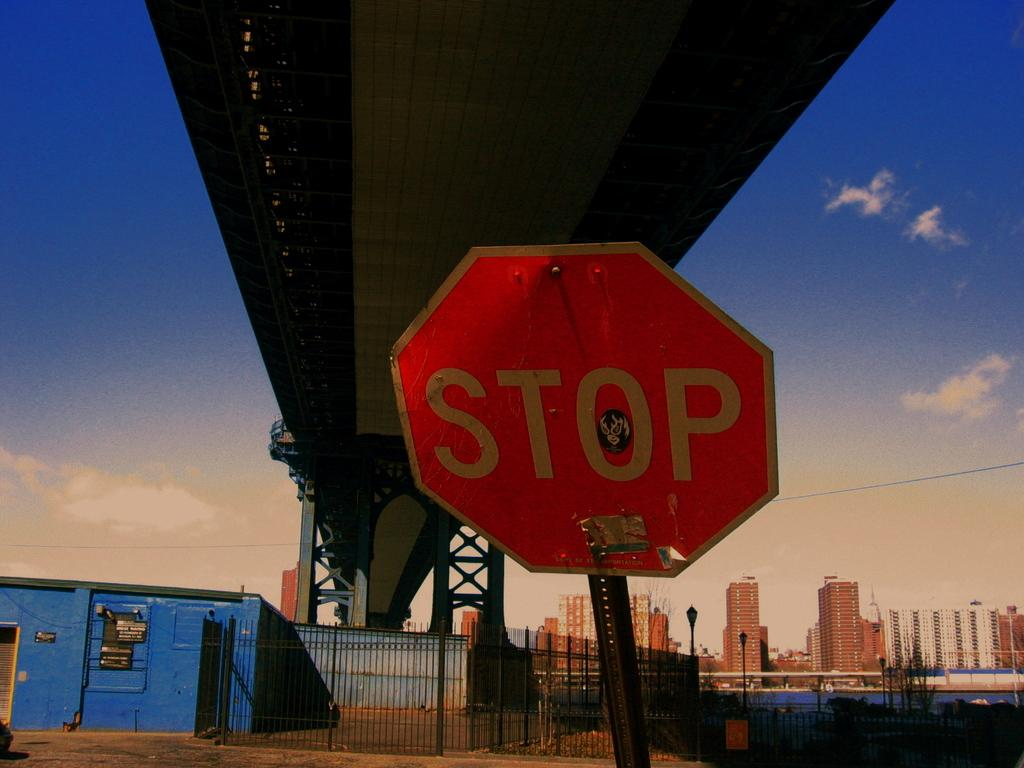Provide a one-sentence caption for the provided image. A RED OCTOGON STOP SIGN UNDER A BRIDGE. 